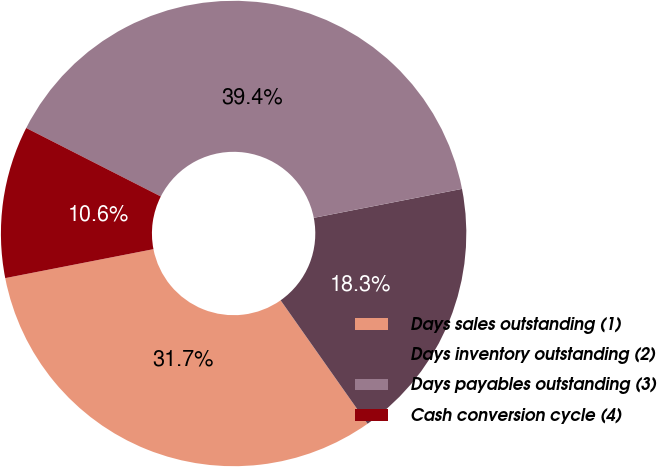<chart> <loc_0><loc_0><loc_500><loc_500><pie_chart><fcel>Days sales outstanding (1)<fcel>Days inventory outstanding (2)<fcel>Days payables outstanding (3)<fcel>Cash conversion cycle (4)<nl><fcel>31.69%<fcel>18.31%<fcel>39.44%<fcel>10.56%<nl></chart> 